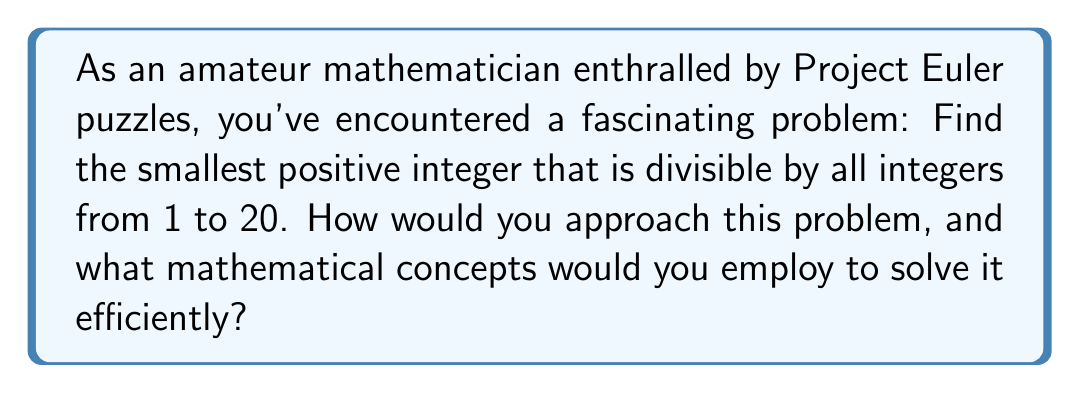Help me with this question. To solve this problem, we'll use the concept of the Least Common Multiple (LCM) and prime factorization. Here's a step-by-step approach:

1) First, let's consider that the LCM of 1 to 20 is our target number.

2) We can simplify our calculation by noting that:
   - Numbers divisible by 20 are also divisible by 1, 2, 4, 5, 10
   - Numbers divisible by 18 are also divisible by 3, 6, 9
   - Numbers divisible by 16 are also divisible by 8
   - 7, 11, 13, 17, 19 are prime and must be considered separately

3) So, we need to find LCM(11, 12, 13, 14, 15, 16, 17, 18, 19, 20)

4) Let's break these numbers into their prime factors:
   $$\begin{align*}
   11 &= 11 \\
   12 &= 2^2 \times 3 \\
   13 &= 13 \\
   14 &= 2 \times 7 \\
   15 &= 3 \times 5 \\
   16 &= 2^4 \\
   17 &= 17 \\
   18 &= 2 \times 3^2 \\
   19 &= 19 \\
   20 &= 2^2 \times 5
   \end{align*}$$

5) To find the LCM, we take each prime factor to the highest power in which it occurs:
   $$2^4 \times 3^2 \times 5 \times 7 \times 11 \times 13 \times 17 \times 19$$

6) Calculate this value:
   $$16 \times 9 \times 5 \times 7 \times 11 \times 13 \times 17 \times 19 = 232,792,560$$

This approach efficiently solves the problem by using prime factorization and the properties of LCM, demonstrating the elegance of number theory in solving seemingly complex problems.
Answer: $232,792,560$ 